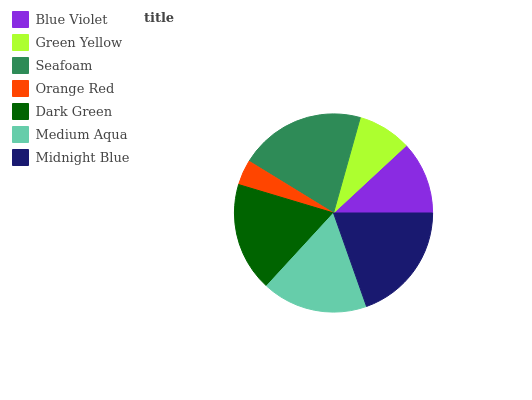Is Orange Red the minimum?
Answer yes or no. Yes. Is Seafoam the maximum?
Answer yes or no. Yes. Is Green Yellow the minimum?
Answer yes or no. No. Is Green Yellow the maximum?
Answer yes or no. No. Is Blue Violet greater than Green Yellow?
Answer yes or no. Yes. Is Green Yellow less than Blue Violet?
Answer yes or no. Yes. Is Green Yellow greater than Blue Violet?
Answer yes or no. No. Is Blue Violet less than Green Yellow?
Answer yes or no. No. Is Medium Aqua the high median?
Answer yes or no. Yes. Is Medium Aqua the low median?
Answer yes or no. Yes. Is Midnight Blue the high median?
Answer yes or no. No. Is Orange Red the low median?
Answer yes or no. No. 